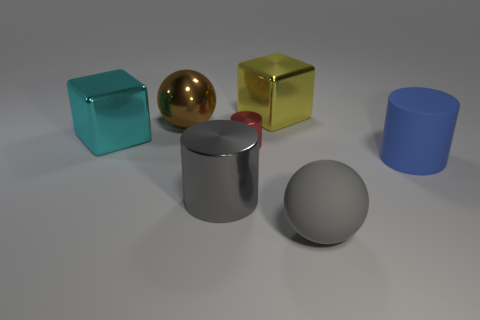Is there any other thing that is the same shape as the yellow metallic object?
Offer a very short reply. Yes. There is a sphere in front of the tiny metallic thing that is on the left side of the big matte thing in front of the gray metallic cylinder; what color is it?
Provide a succinct answer. Gray. How many small objects are either green rubber blocks or cyan objects?
Make the answer very short. 0. Is the number of tiny metal cylinders that are right of the gray metal cylinder the same as the number of blue cylinders?
Your response must be concise. Yes. There is a red object; are there any blocks right of it?
Your answer should be compact. Yes. What number of metal objects are gray blocks or brown things?
Give a very brief answer. 1. There is a big rubber cylinder; how many cyan things are in front of it?
Offer a very short reply. 0. Is there a blue cylinder that has the same size as the gray rubber sphere?
Provide a succinct answer. Yes. Are there any other large balls of the same color as the large shiny ball?
Provide a succinct answer. No. Are there any other things that are the same size as the red object?
Your answer should be very brief. No. 